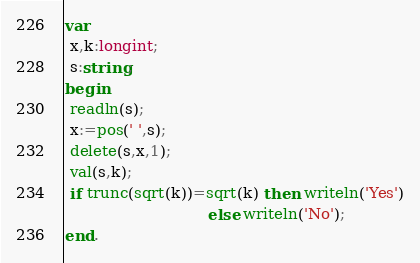Convert code to text. <code><loc_0><loc_0><loc_500><loc_500><_Pascal_>var
 x,k:longint;
 s:string;
begin
 readln(s);
 x:=pos(' ',s);
 delete(s,x,1);
 val(s,k);
 if trunc(sqrt(k))=sqrt(k) then writeln('Yes')
                              else writeln('No');
end.</code> 